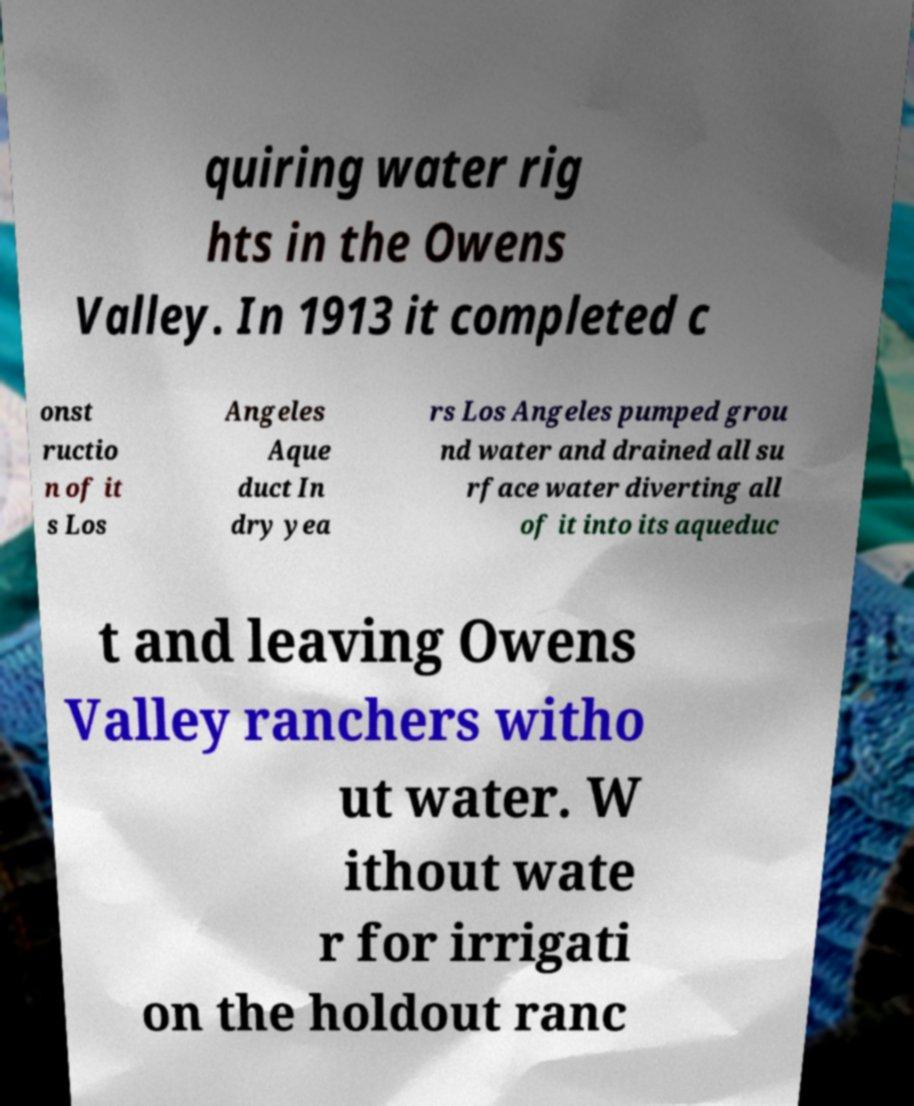Can you read and provide the text displayed in the image?This photo seems to have some interesting text. Can you extract and type it out for me? quiring water rig hts in the Owens Valley. In 1913 it completed c onst ructio n of it s Los Angeles Aque duct In dry yea rs Los Angeles pumped grou nd water and drained all su rface water diverting all of it into its aqueduc t and leaving Owens Valley ranchers witho ut water. W ithout wate r for irrigati on the holdout ranc 